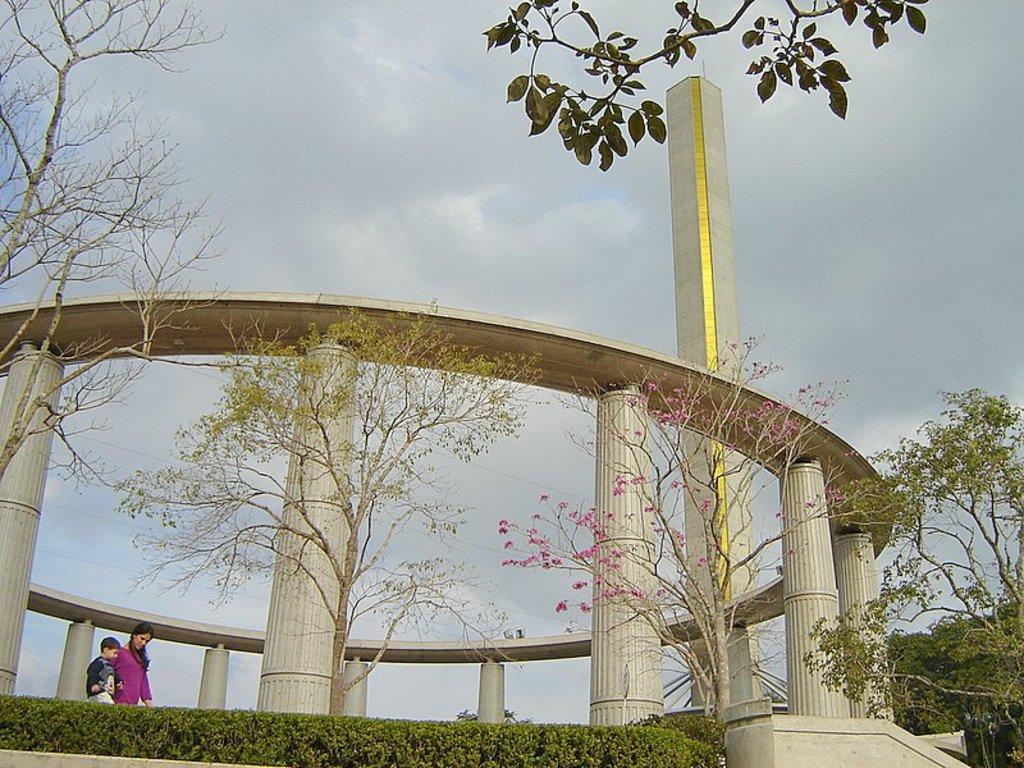What are the two people in the image doing? The two people in the image are walking. Where are the people walking? The people are walking on a road. What can be seen in the background of the image? There are trees, at least one building, and the sky visible in the background of the image. What type of root can be seen growing on the building in the image? There is no root growing on the building in the image. What scientific discovery is being made by the people walking in the image? The image does not depict any scientific discovery being made by the people walking. 